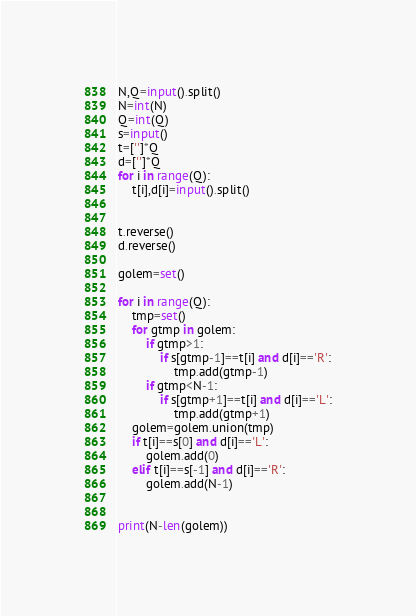<code> <loc_0><loc_0><loc_500><loc_500><_Python_>N,Q=input().split()
N=int(N)
Q=int(Q)
s=input()
t=['']*Q
d=['']*Q
for i in range(Q):
    t[i],d[i]=input().split()

    
t.reverse()
d.reverse()

golem=set()

for i in range(Q):
    tmp=set()
    for gtmp in golem:
        if gtmp>1:
            if s[gtmp-1]==t[i] and d[i]=='R':
                tmp.add(gtmp-1)
        if gtmp<N-1:
            if s[gtmp+1]==t[i] and d[i]=='L':
                tmp.add(gtmp+1)
    golem=golem.union(tmp)
    if t[i]==s[0] and d[i]=='L':
        golem.add(0)
    elif t[i]==s[-1] and d[i]=='R':
        golem.add(N-1)

        
print(N-len(golem))
</code> 